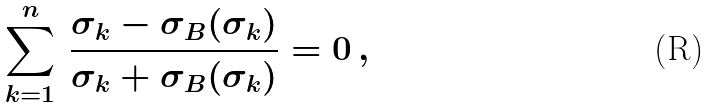<formula> <loc_0><loc_0><loc_500><loc_500>\sum _ { k = 1 } ^ { n } \, \frac { \sigma _ { k } - \sigma _ { B } ( \sigma _ { k } ) } { \sigma _ { k } + \sigma _ { B } ( \sigma _ { k } ) } = 0 \, ,</formula> 